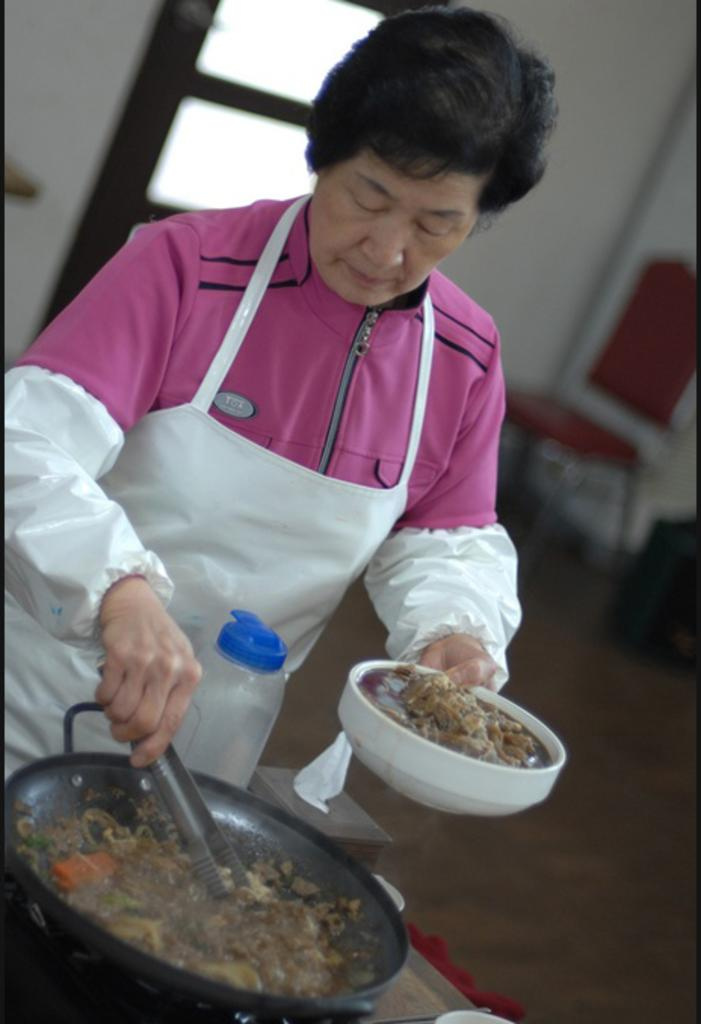Who is present in the image? There is a woman in the image. What is the woman wearing? The woman is wearing a jacket. What is the woman doing in the image? The woman is cooking. What is the woman holding in her hand? The woman is holding a bowl in her hand. What can be seen in the pan? There is food in a pan. What can be seen in the background of the image? There is a window, a wall, and a chair in the background of the image. What type of knowledge can be seen in the image? There is no knowledge present in the image; it features a woman cooking with a bowl and food in a pan. What type of vest is the woman wearing in the image? The woman is not wearing a vest in the image; she is wearing a jacket. 